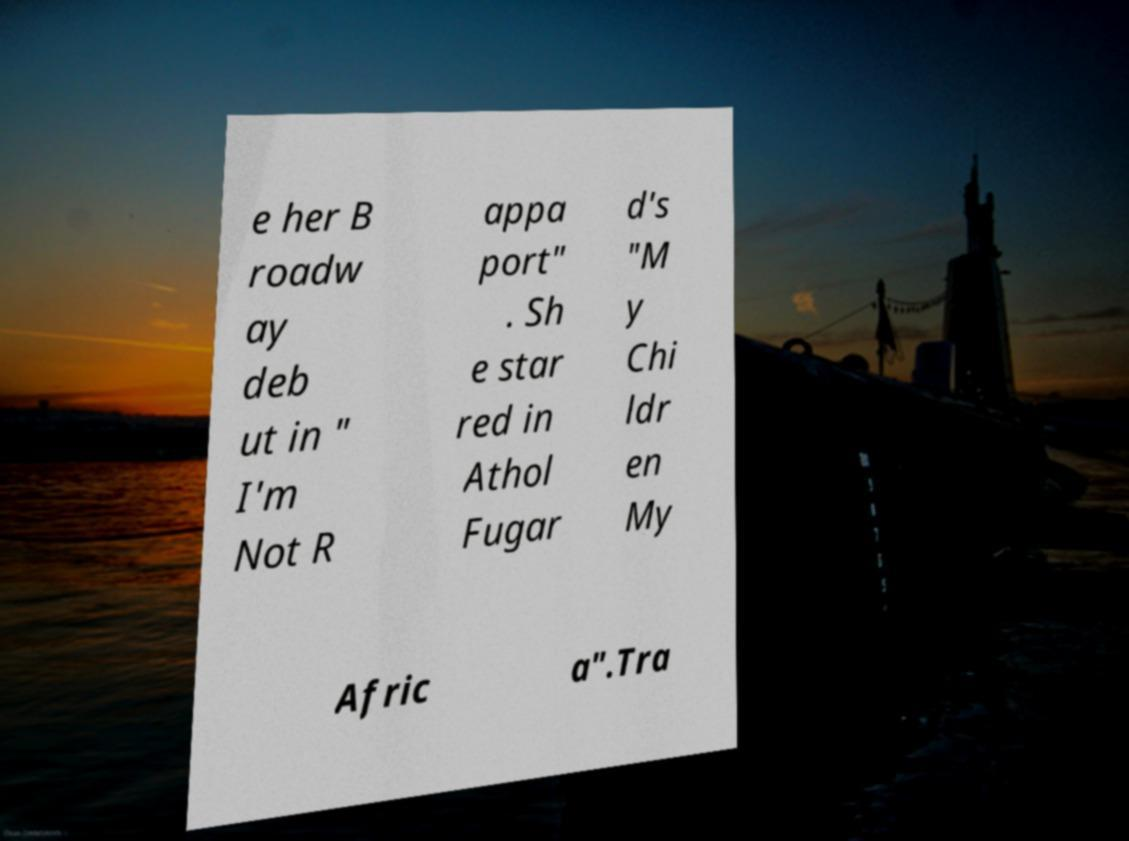For documentation purposes, I need the text within this image transcribed. Could you provide that? e her B roadw ay deb ut in " I'm Not R appa port" . Sh e star red in Athol Fugar d's "M y Chi ldr en My Afric a".Tra 